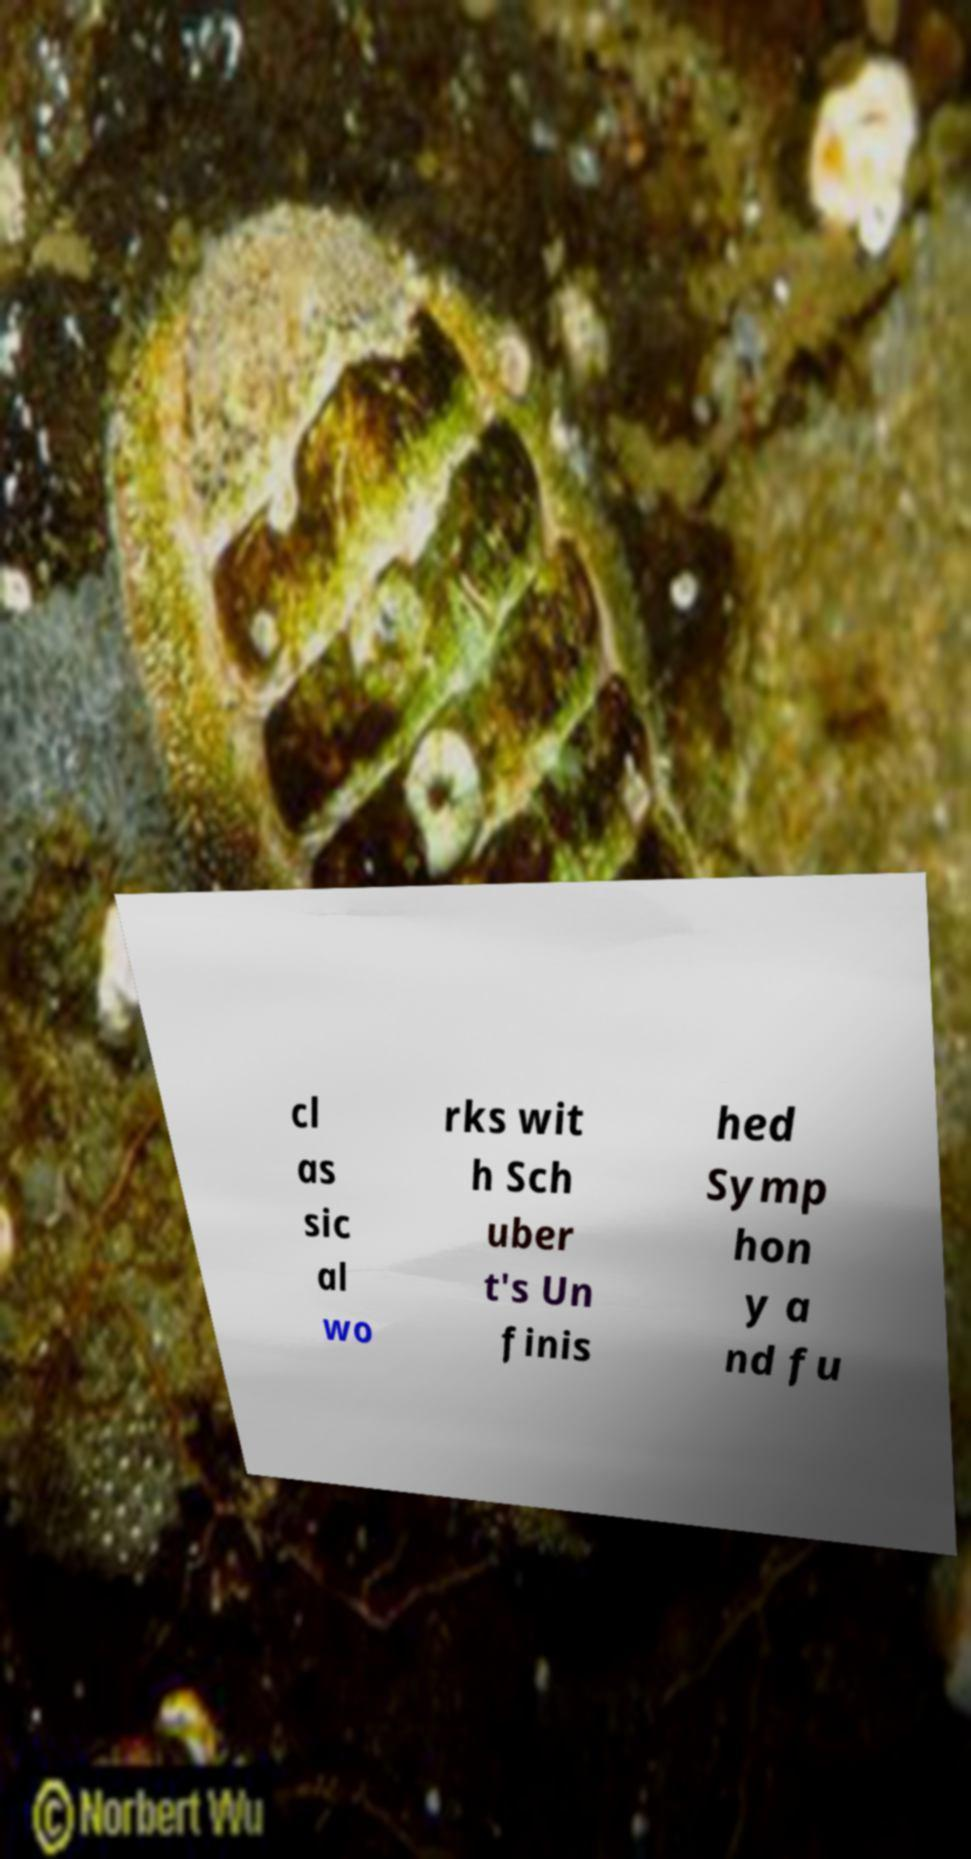Please read and relay the text visible in this image. What does it say? cl as sic al wo rks wit h Sch uber t's Un finis hed Symp hon y a nd fu 